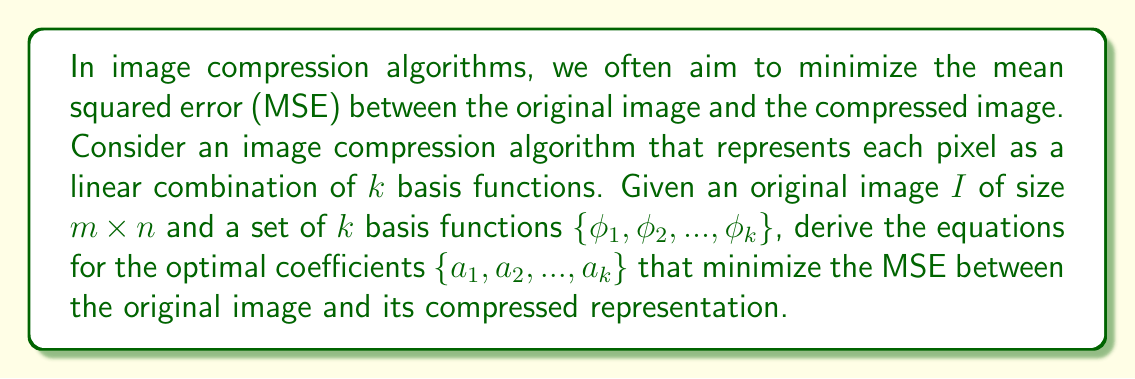Solve this math problem. To solve this problem, we'll follow these steps:

1) First, let's define the compressed representation of the image:

   $$\hat{I}(x,y) = \sum_{i=1}^k a_i \phi_i(x,y)$$

   where $\hat{I}(x,y)$ is the pixel value at position $(x,y)$ in the compressed image.

2) The mean squared error (MSE) between the original image $I$ and the compressed image $\hat{I}$ is:

   $$MSE = \frac{1}{mn} \sum_{x=1}^m \sum_{y=1}^n [I(x,y) - \hat{I}(x,y)]^2$$

3) Substituting the expression for $\hat{I}(x,y)$:

   $$MSE = \frac{1}{mn} \sum_{x=1}^m \sum_{y=1}^n [I(x,y) - \sum_{i=1}^k a_i \phi_i(x,y)]^2$$

4) To minimize the MSE, we need to find the values of $a_i$ that make the partial derivatives of MSE with respect to each $a_i$ equal to zero:

   $$\frac{\partial MSE}{\partial a_j} = 0, \quad \text{for } j = 1, 2, ..., k$$

5) Computing the partial derivative:

   $$\frac{\partial MSE}{\partial a_j} = \frac{2}{mn} \sum_{x=1}^m \sum_{y=1}^n [I(x,y) - \sum_{i=1}^k a_i \phi_i(x,y)] (-\phi_j(x,y)) = 0$$

6) Simplifying:

   $$\sum_{x=1}^m \sum_{y=1}^n I(x,y)\phi_j(x,y) = \sum_{i=1}^k a_i \sum_{x=1}^m \sum_{y=1}^n \phi_i(x,y)\phi_j(x,y)$$

7) This gives us a system of $k$ linear equations. We can write this in matrix form:

   $$\mathbf{A}\mathbf{a} = \mathbf{b}$$

   where:
   - $\mathbf{A}$ is a $k \times k$ matrix with elements $A_{ij} = \sum_{x=1}^m \sum_{y=1}^n \phi_i(x,y)\phi_j(x,y)$
   - $\mathbf{a}$ is a $k \times 1$ vector of the unknown coefficients $a_i$
   - $\mathbf{b}$ is a $k \times 1$ vector with elements $b_j = \sum_{x=1}^m \sum_{y=1}^n I(x,y)\phi_j(x,y)$

8) The solution to this system of equations gives the optimal coefficients that minimize the MSE.
Answer: The optimal coefficients $\{a_1, a_2, ..., a_k\}$ that minimize the MSE can be found by solving the linear system:

$$\mathbf{A}\mathbf{a} = \mathbf{b}$$

where:
$$A_{ij} = \sum_{x=1}^m \sum_{y=1}^n \phi_i(x,y)\phi_j(x,y)$$
$$b_j = \sum_{x=1}^m \sum_{y=1}^n I(x,y)\phi_j(x,y)$$

The solution is given by:

$$\mathbf{a} = \mathbf{A}^{-1}\mathbf{b}$$

assuming $\mathbf{A}$ is invertible. 